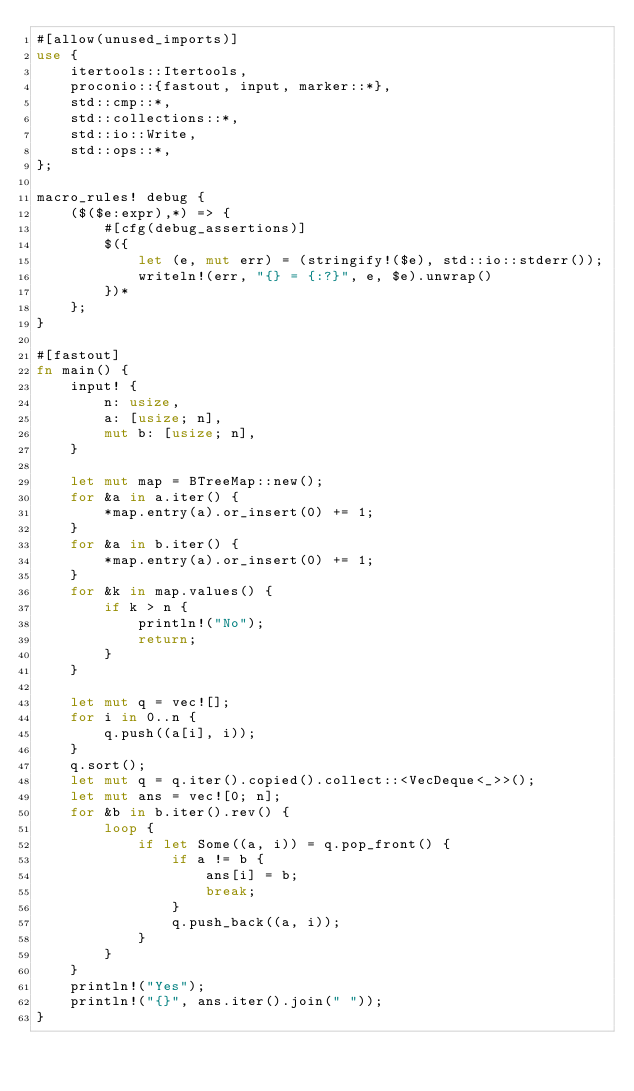Convert code to text. <code><loc_0><loc_0><loc_500><loc_500><_Rust_>#[allow(unused_imports)]
use {
    itertools::Itertools,
    proconio::{fastout, input, marker::*},
    std::cmp::*,
    std::collections::*,
    std::io::Write,
    std::ops::*,
};

macro_rules! debug {
    ($($e:expr),*) => {
        #[cfg(debug_assertions)]
        $({
            let (e, mut err) = (stringify!($e), std::io::stderr());
            writeln!(err, "{} = {:?}", e, $e).unwrap()
        })*
    };
}

#[fastout]
fn main() {
    input! {
        n: usize,
        a: [usize; n],
        mut b: [usize; n],
    }

    let mut map = BTreeMap::new();
    for &a in a.iter() {
        *map.entry(a).or_insert(0) += 1;
    }
    for &a in b.iter() {
        *map.entry(a).or_insert(0) += 1;
    }
    for &k in map.values() {
        if k > n {
            println!("No");
            return;
        }
    }

    let mut q = vec![];
    for i in 0..n {
        q.push((a[i], i));
    }
    q.sort();
    let mut q = q.iter().copied().collect::<VecDeque<_>>();
    let mut ans = vec![0; n];
    for &b in b.iter().rev() {
        loop {
            if let Some((a, i)) = q.pop_front() {
                if a != b {
                    ans[i] = b;
                    break;
                }
                q.push_back((a, i));
            }
        }
    }
    println!("Yes");
    println!("{}", ans.iter().join(" "));
}
</code> 